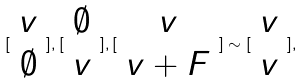<formula> <loc_0><loc_0><loc_500><loc_500>[ \begin{array} { c } v \\ \emptyset \end{array} ] , [ \begin{array} { c } \emptyset \\ v \end{array} ] , [ \begin{array} { c } v \\ v + F \end{array} ] \sim [ \begin{array} { c } v \\ v \end{array} ] ,</formula> 